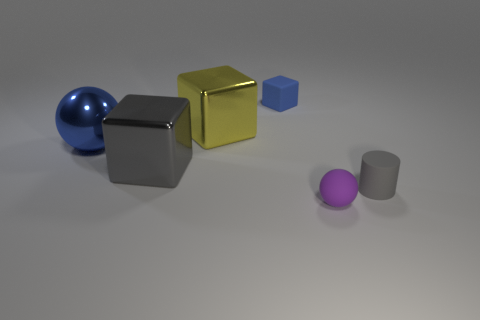Are there any other things that are the same shape as the small gray matte thing?
Keep it short and to the point. No. What number of small spheres are made of the same material as the small cylinder?
Provide a succinct answer. 1. What material is the small purple sphere?
Provide a succinct answer. Rubber. There is a gray object left of the ball in front of the small cylinder; what is its shape?
Offer a terse response. Cube. What shape is the thing in front of the gray cylinder?
Make the answer very short. Sphere. How many large metal spheres have the same color as the rubber cube?
Your answer should be very brief. 1. What color is the small rubber cylinder?
Your answer should be very brief. Gray. How many gray things are to the left of the gray thing that is on the right side of the tiny blue rubber cube?
Your answer should be compact. 1. Is the size of the yellow metal thing the same as the ball that is to the left of the purple matte sphere?
Make the answer very short. Yes. Does the metallic sphere have the same size as the yellow object?
Offer a terse response. Yes. 